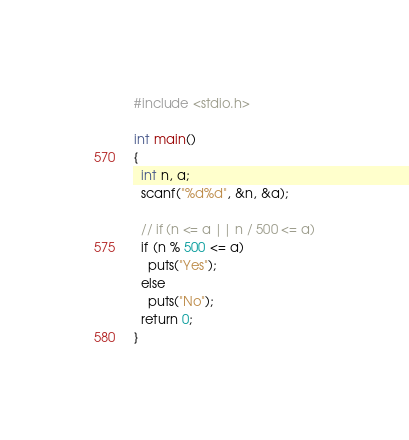Convert code to text. <code><loc_0><loc_0><loc_500><loc_500><_C_>#include <stdio.h>

int main()
{
  int n, a;
  scanf("%d%d", &n, &a);

  // if (n <= a || n / 500 <= a)
  if (n % 500 <= a)
    puts("Yes");
  else
    puts("No");
  return 0;
}</code> 